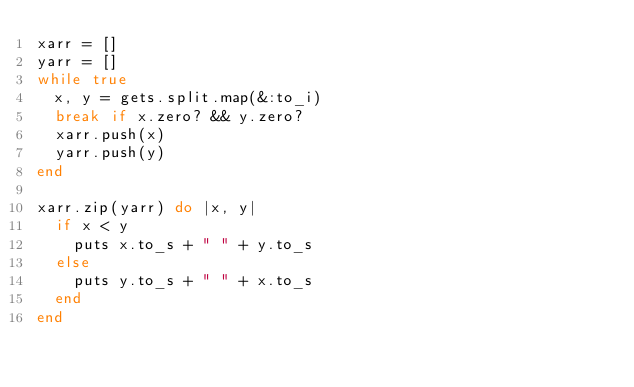Convert code to text. <code><loc_0><loc_0><loc_500><loc_500><_Ruby_>xarr = [] 
yarr = []
while true
  x, y = gets.split.map(&:to_i)
  break if x.zero? && y.zero?
  xarr.push(x)
  yarr.push(y)
end

xarr.zip(yarr) do |x, y|
  if x < y
    puts x.to_s + " " + y.to_s
  else
    puts y.to_s + " " + x.to_s
  end
end

</code> 